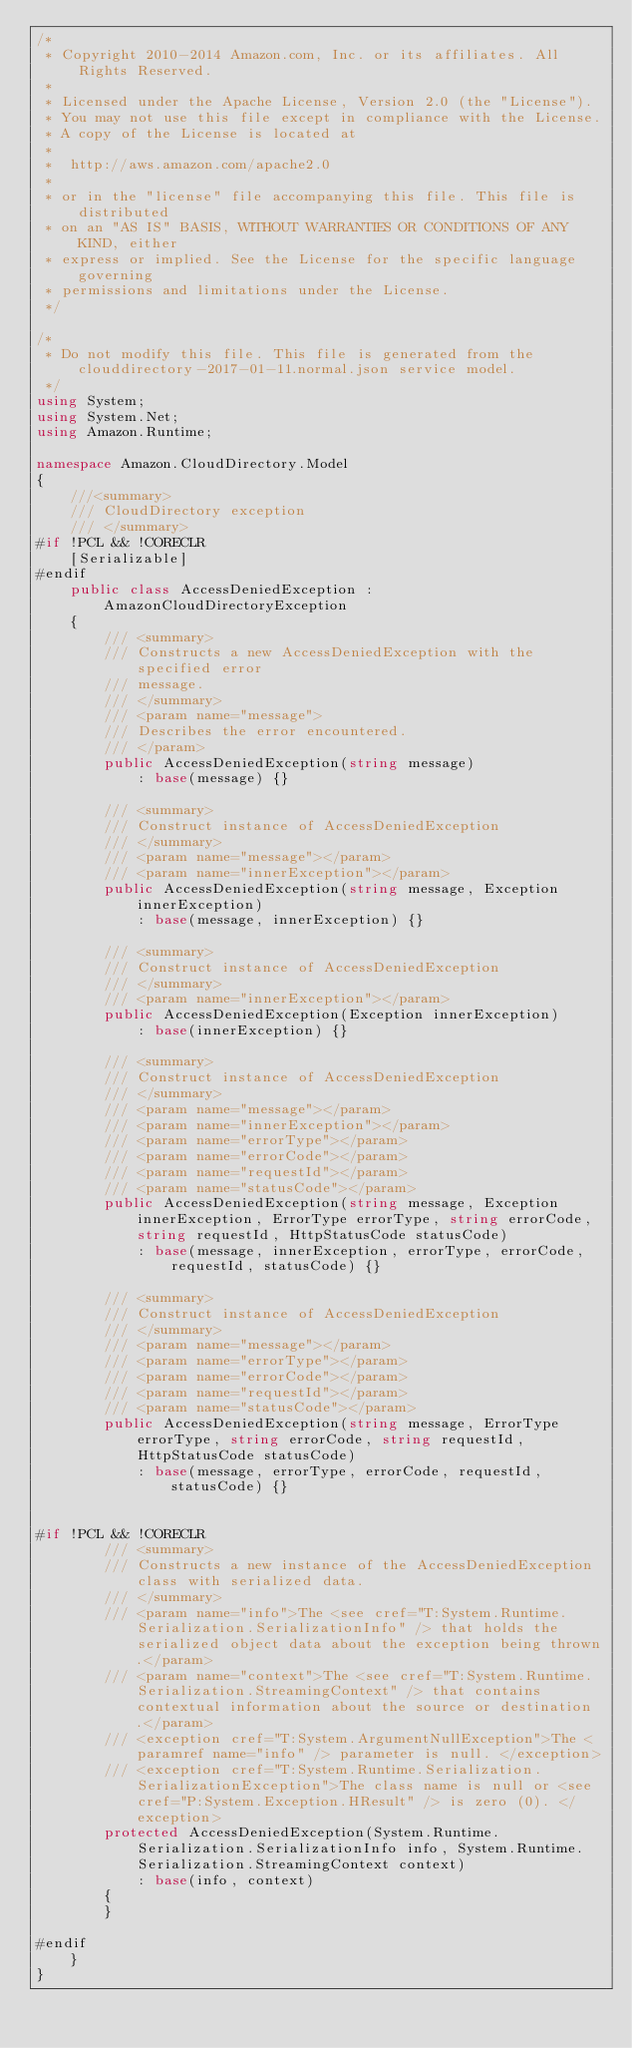<code> <loc_0><loc_0><loc_500><loc_500><_C#_>/*
 * Copyright 2010-2014 Amazon.com, Inc. or its affiliates. All Rights Reserved.
 * 
 * Licensed under the Apache License, Version 2.0 (the "License").
 * You may not use this file except in compliance with the License.
 * A copy of the License is located at
 * 
 *  http://aws.amazon.com/apache2.0
 * 
 * or in the "license" file accompanying this file. This file is distributed
 * on an "AS IS" BASIS, WITHOUT WARRANTIES OR CONDITIONS OF ANY KIND, either
 * express or implied. See the License for the specific language governing
 * permissions and limitations under the License.
 */

/*
 * Do not modify this file. This file is generated from the clouddirectory-2017-01-11.normal.json service model.
 */
using System;
using System.Net;
using Amazon.Runtime;

namespace Amazon.CloudDirectory.Model
{
    ///<summary>
    /// CloudDirectory exception
    /// </summary>
#if !PCL && !CORECLR
    [Serializable]
#endif
    public class AccessDeniedException : AmazonCloudDirectoryException 
    {
        /// <summary>
        /// Constructs a new AccessDeniedException with the specified error
        /// message.
        /// </summary>
        /// <param name="message">
        /// Describes the error encountered.
        /// </param>
        public AccessDeniedException(string message) 
            : base(message) {}
          
        /// <summary>
        /// Construct instance of AccessDeniedException
        /// </summary>
        /// <param name="message"></param>
        /// <param name="innerException"></param>
        public AccessDeniedException(string message, Exception innerException) 
            : base(message, innerException) {}
            
        /// <summary>
        /// Construct instance of AccessDeniedException
        /// </summary>
        /// <param name="innerException"></param>
        public AccessDeniedException(Exception innerException) 
            : base(innerException) {}
            
        /// <summary>
        /// Construct instance of AccessDeniedException
        /// </summary>
        /// <param name="message"></param>
        /// <param name="innerException"></param>
        /// <param name="errorType"></param>
        /// <param name="errorCode"></param>
        /// <param name="requestId"></param>
        /// <param name="statusCode"></param>
        public AccessDeniedException(string message, Exception innerException, ErrorType errorType, string errorCode, string requestId, HttpStatusCode statusCode) 
            : base(message, innerException, errorType, errorCode, requestId, statusCode) {}

        /// <summary>
        /// Construct instance of AccessDeniedException
        /// </summary>
        /// <param name="message"></param>
        /// <param name="errorType"></param>
        /// <param name="errorCode"></param>
        /// <param name="requestId"></param>
        /// <param name="statusCode"></param>
        public AccessDeniedException(string message, ErrorType errorType, string errorCode, string requestId, HttpStatusCode statusCode) 
            : base(message, errorType, errorCode, requestId, statusCode) {}


#if !PCL && !CORECLR
        /// <summary>
        /// Constructs a new instance of the AccessDeniedException class with serialized data.
        /// </summary>
        /// <param name="info">The <see cref="T:System.Runtime.Serialization.SerializationInfo" /> that holds the serialized object data about the exception being thrown.</param>
        /// <param name="context">The <see cref="T:System.Runtime.Serialization.StreamingContext" /> that contains contextual information about the source or destination.</param>
        /// <exception cref="T:System.ArgumentNullException">The <paramref name="info" /> parameter is null. </exception>
        /// <exception cref="T:System.Runtime.Serialization.SerializationException">The class name is null or <see cref="P:System.Exception.HResult" /> is zero (0). </exception>
        protected AccessDeniedException(System.Runtime.Serialization.SerializationInfo info, System.Runtime.Serialization.StreamingContext context)
            : base(info, context)
        {
        }

#endif
    }
}</code> 